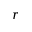Convert formula to latex. <formula><loc_0><loc_0><loc_500><loc_500>r</formula> 